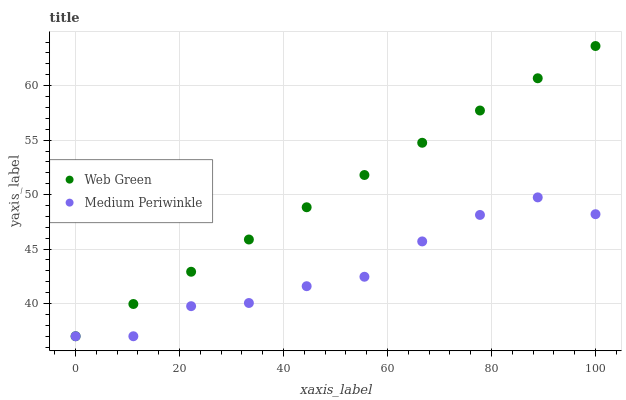Does Medium Periwinkle have the minimum area under the curve?
Answer yes or no. Yes. Does Web Green have the maximum area under the curve?
Answer yes or no. Yes. Does Web Green have the minimum area under the curve?
Answer yes or no. No. Is Web Green the smoothest?
Answer yes or no. Yes. Is Medium Periwinkle the roughest?
Answer yes or no. Yes. Is Web Green the roughest?
Answer yes or no. No. Does Medium Periwinkle have the lowest value?
Answer yes or no. Yes. Does Web Green have the highest value?
Answer yes or no. Yes. Does Web Green intersect Medium Periwinkle?
Answer yes or no. Yes. Is Web Green less than Medium Periwinkle?
Answer yes or no. No. Is Web Green greater than Medium Periwinkle?
Answer yes or no. No. 